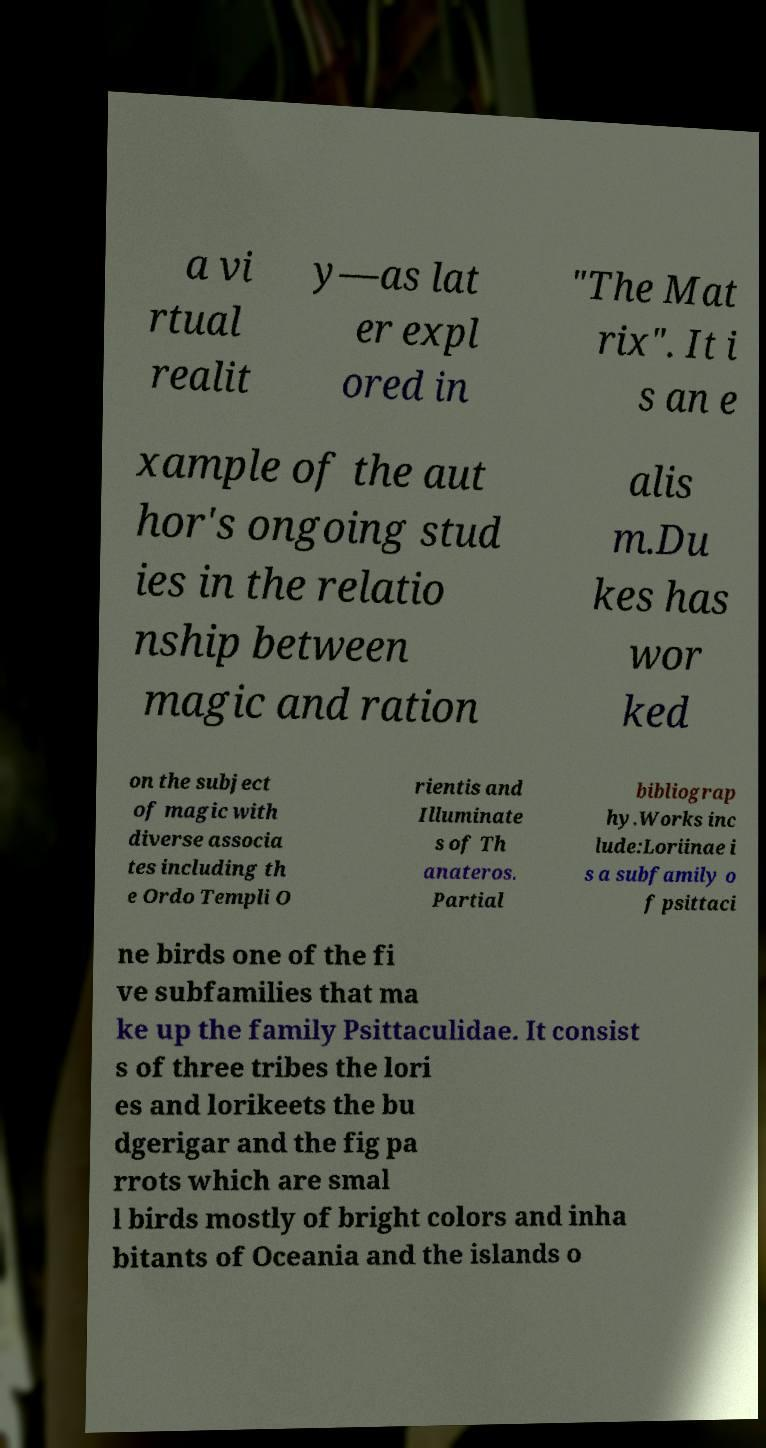Please identify and transcribe the text found in this image. a vi rtual realit y—as lat er expl ored in "The Mat rix". It i s an e xample of the aut hor's ongoing stud ies in the relatio nship between magic and ration alis m.Du kes has wor ked on the subject of magic with diverse associa tes including th e Ordo Templi O rientis and Illuminate s of Th anateros. Partial bibliograp hy.Works inc lude:Loriinae i s a subfamily o f psittaci ne birds one of the fi ve subfamilies that ma ke up the family Psittaculidae. It consist s of three tribes the lori es and lorikeets the bu dgerigar and the fig pa rrots which are smal l birds mostly of bright colors and inha bitants of Oceania and the islands o 